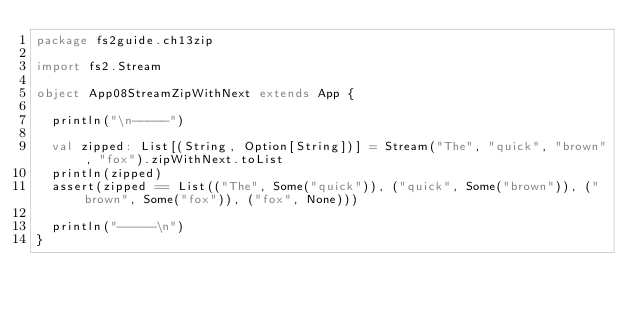Convert code to text. <code><loc_0><loc_0><loc_500><loc_500><_Scala_>package fs2guide.ch13zip

import fs2.Stream

object App08StreamZipWithNext extends App {

  println("\n-----")

  val zipped: List[(String, Option[String])] = Stream("The", "quick", "brown", "fox").zipWithNext.toList
  println(zipped)
  assert(zipped == List(("The", Some("quick")), ("quick", Some("brown")), ("brown", Some("fox")), ("fox", None)))

  println("-----\n")
}
</code> 